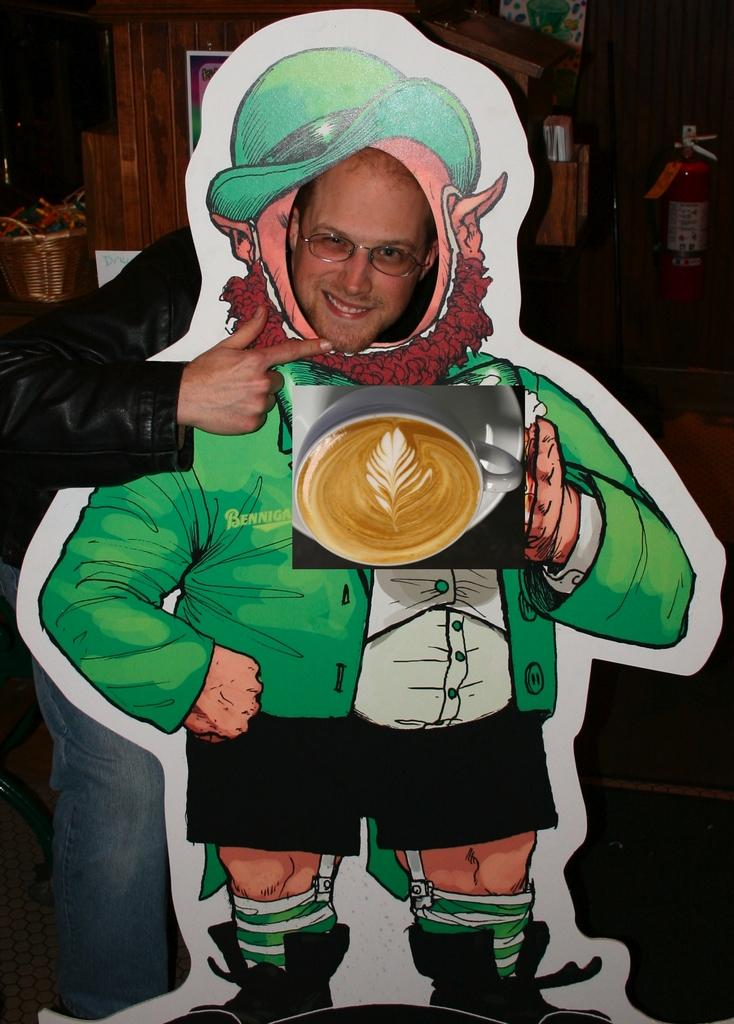What is the person in the image doing? The person is standing behind a cartoon board in the image. What can be seen in the background of the image? There is a wall and a basket in the background of the image. What safety device is present on the wall? There is a fire extinguisher on the wall in the image. What letter is the doctor folding in the image? There is no doctor or letter present in the image. The person is standing behind a cartoon board, and there is a wall, fire extinguisher, and basket in the background. 